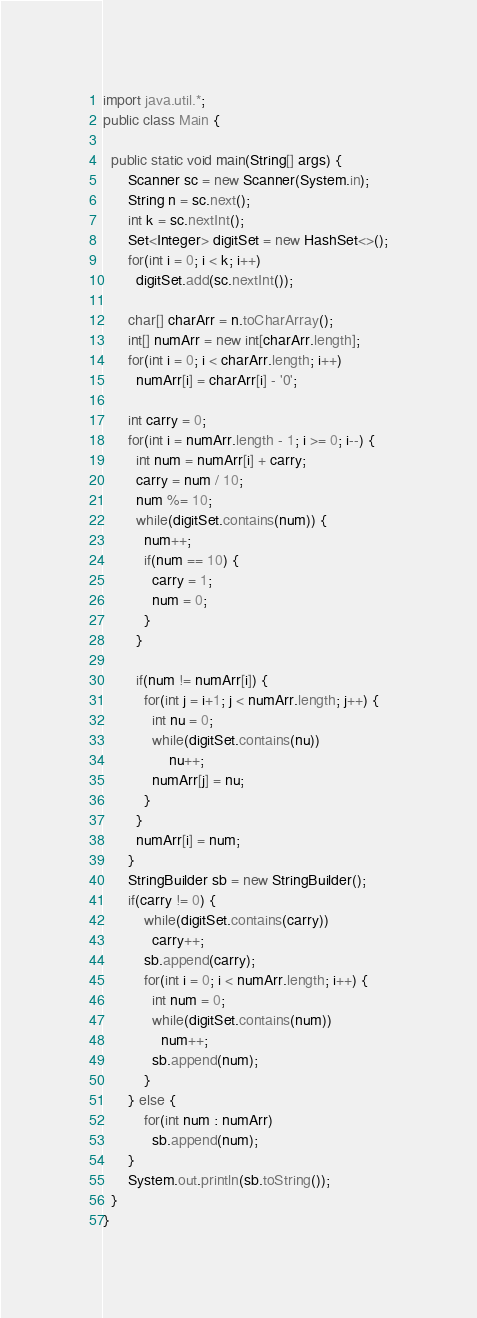<code> <loc_0><loc_0><loc_500><loc_500><_Java_>import java.util.*;
public class Main {

  public static void main(String[] args) { 
      Scanner sc = new Scanner(System.in);
      String n = sc.next();
      int k = sc.nextInt();
      Set<Integer> digitSet = new HashSet<>();
      for(int i = 0; i < k; i++)
        digitSet.add(sc.nextInt());

      char[] charArr = n.toCharArray();
      int[] numArr = new int[charArr.length];
      for(int i = 0; i < charArr.length; i++)
        numArr[i] = charArr[i] - '0';

      int carry = 0;
      for(int i = numArr.length - 1; i >= 0; i--) {
        int num = numArr[i] + carry;
        carry = num / 10;
        num %= 10;
        while(digitSet.contains(num)) {
          num++;
          if(num == 10) {
            carry = 1;
            num = 0;
          }
        }
        
        if(num != numArr[i]) {
          for(int j = i+1; j < numArr.length; j++) {
            int nu = 0;
            while(digitSet.contains(nu))
                nu++;
            numArr[j] = nu;
          }
        }
        numArr[i] = num;
      }
      StringBuilder sb = new StringBuilder();
      if(carry != 0) {
          while(digitSet.contains(carry))
            carry++;
          sb.append(carry);
          for(int i = 0; i < numArr.length; i++) {
            int num = 0;
            while(digitSet.contains(num))
              num++;
            sb.append(num);  
          }
      } else {
          for(int num : numArr)
            sb.append(num);
      }
      System.out.println(sb.toString());
  }
}</code> 